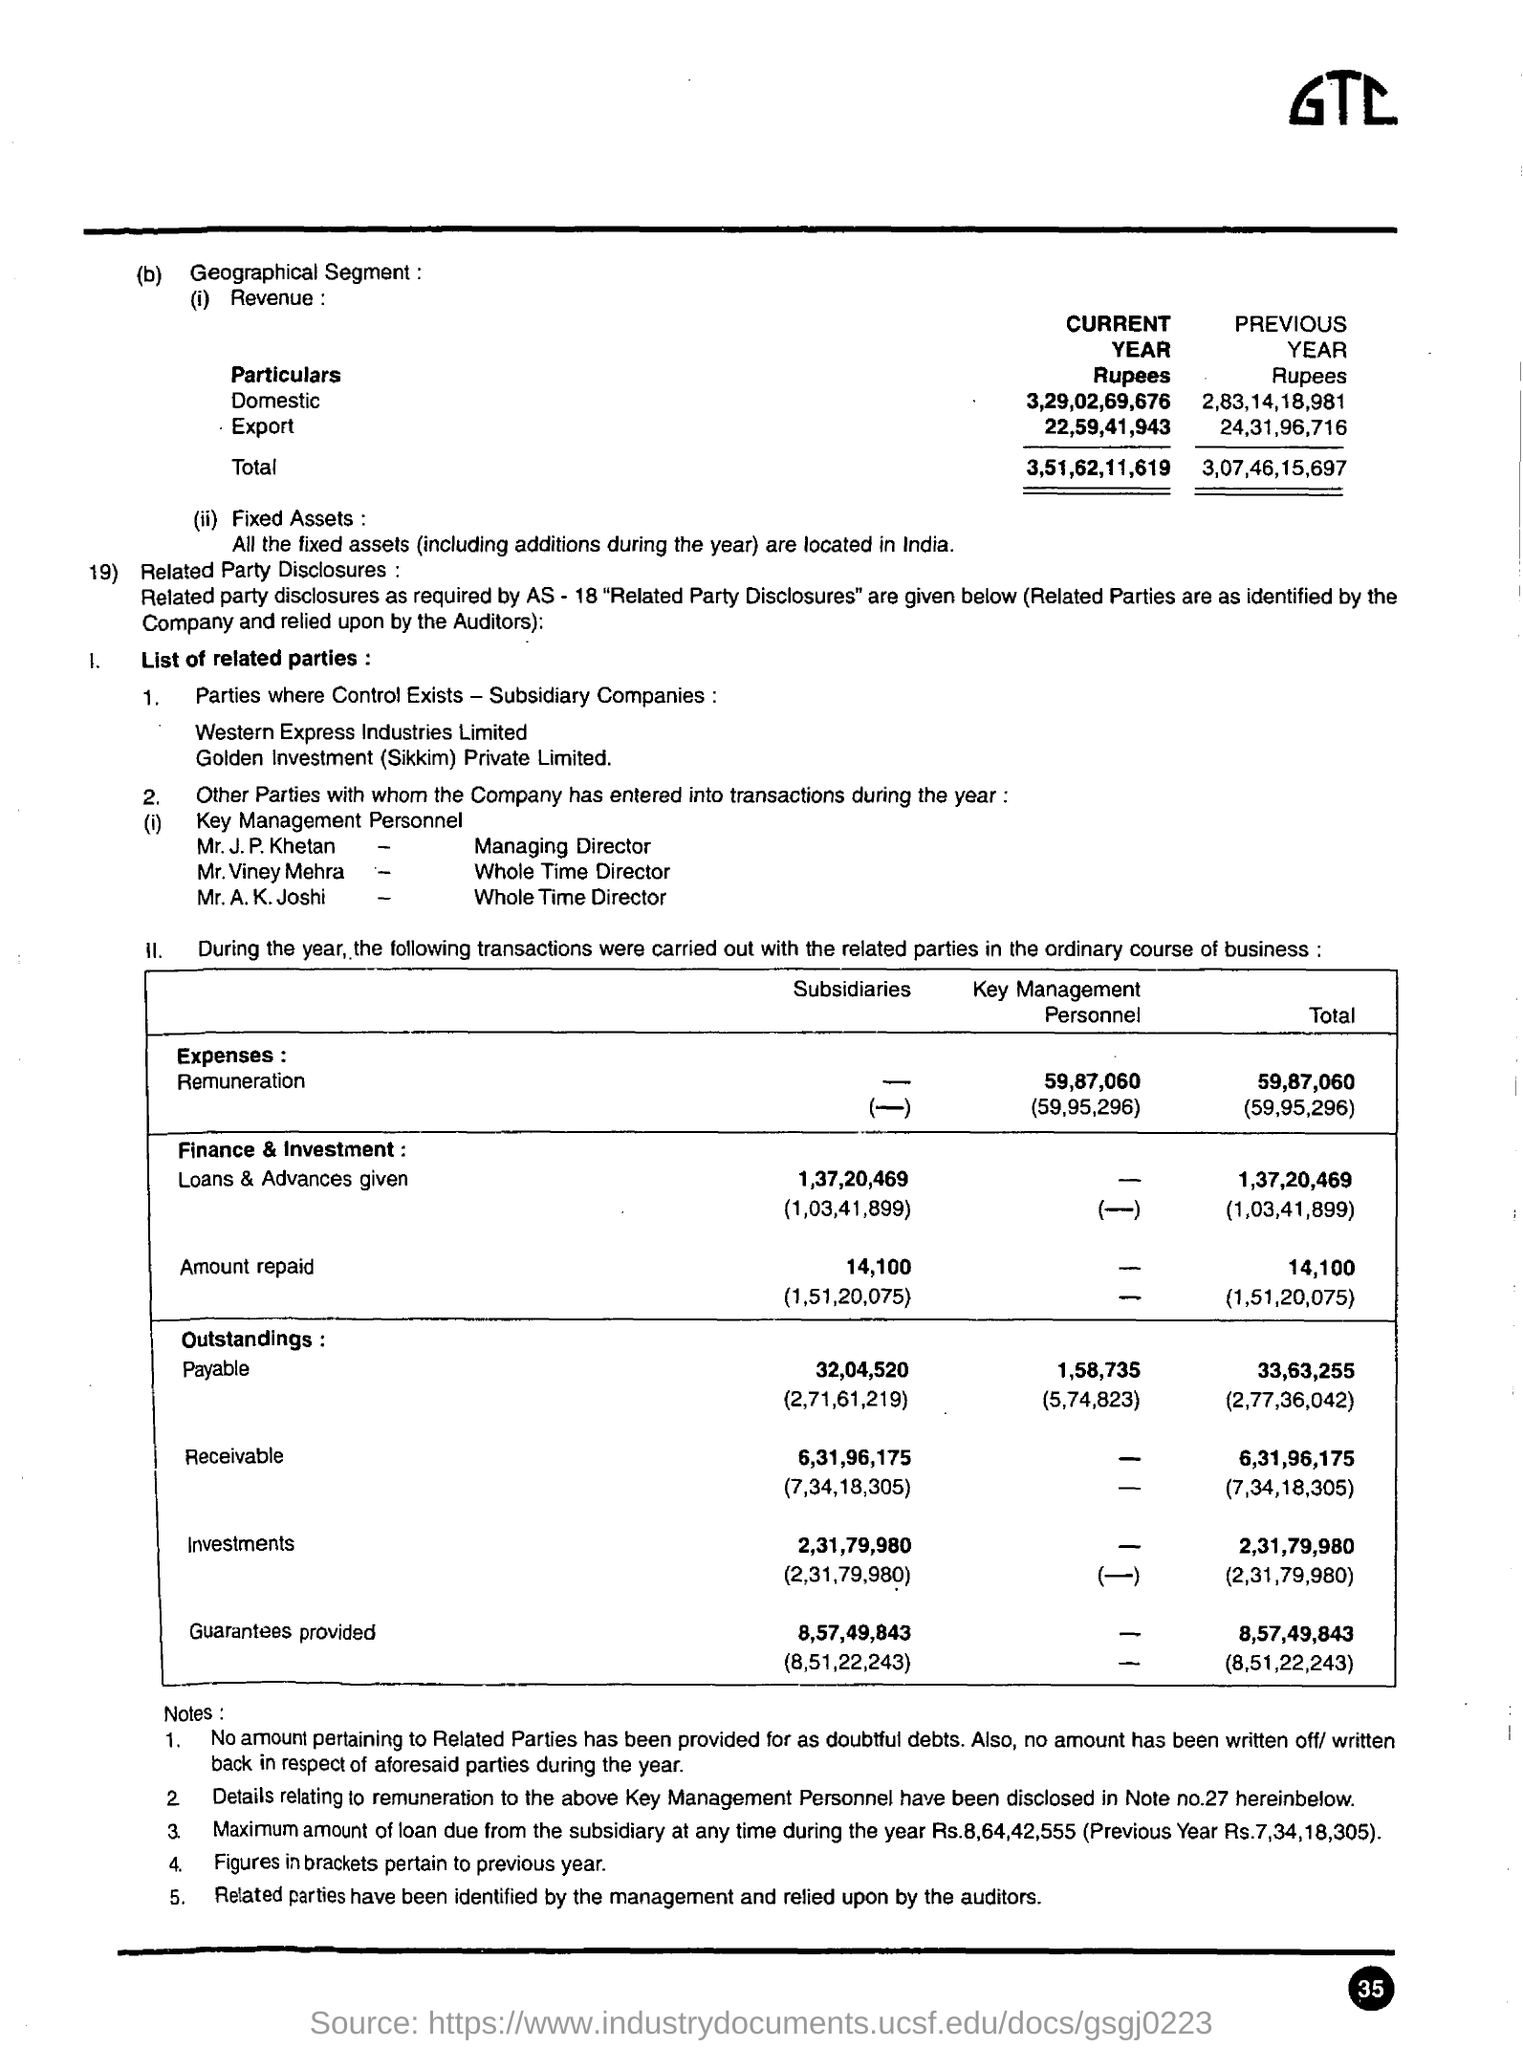What is the total revenue for the current year ?
Provide a short and direct response. 3,51,62,11,619. How  much amount is repaid in the subsidiaries ?
Your answer should be compact. 14,100. In the outstandings payable how much is paid in the subsidiaries ?
Make the answer very short. 32,04,520. 